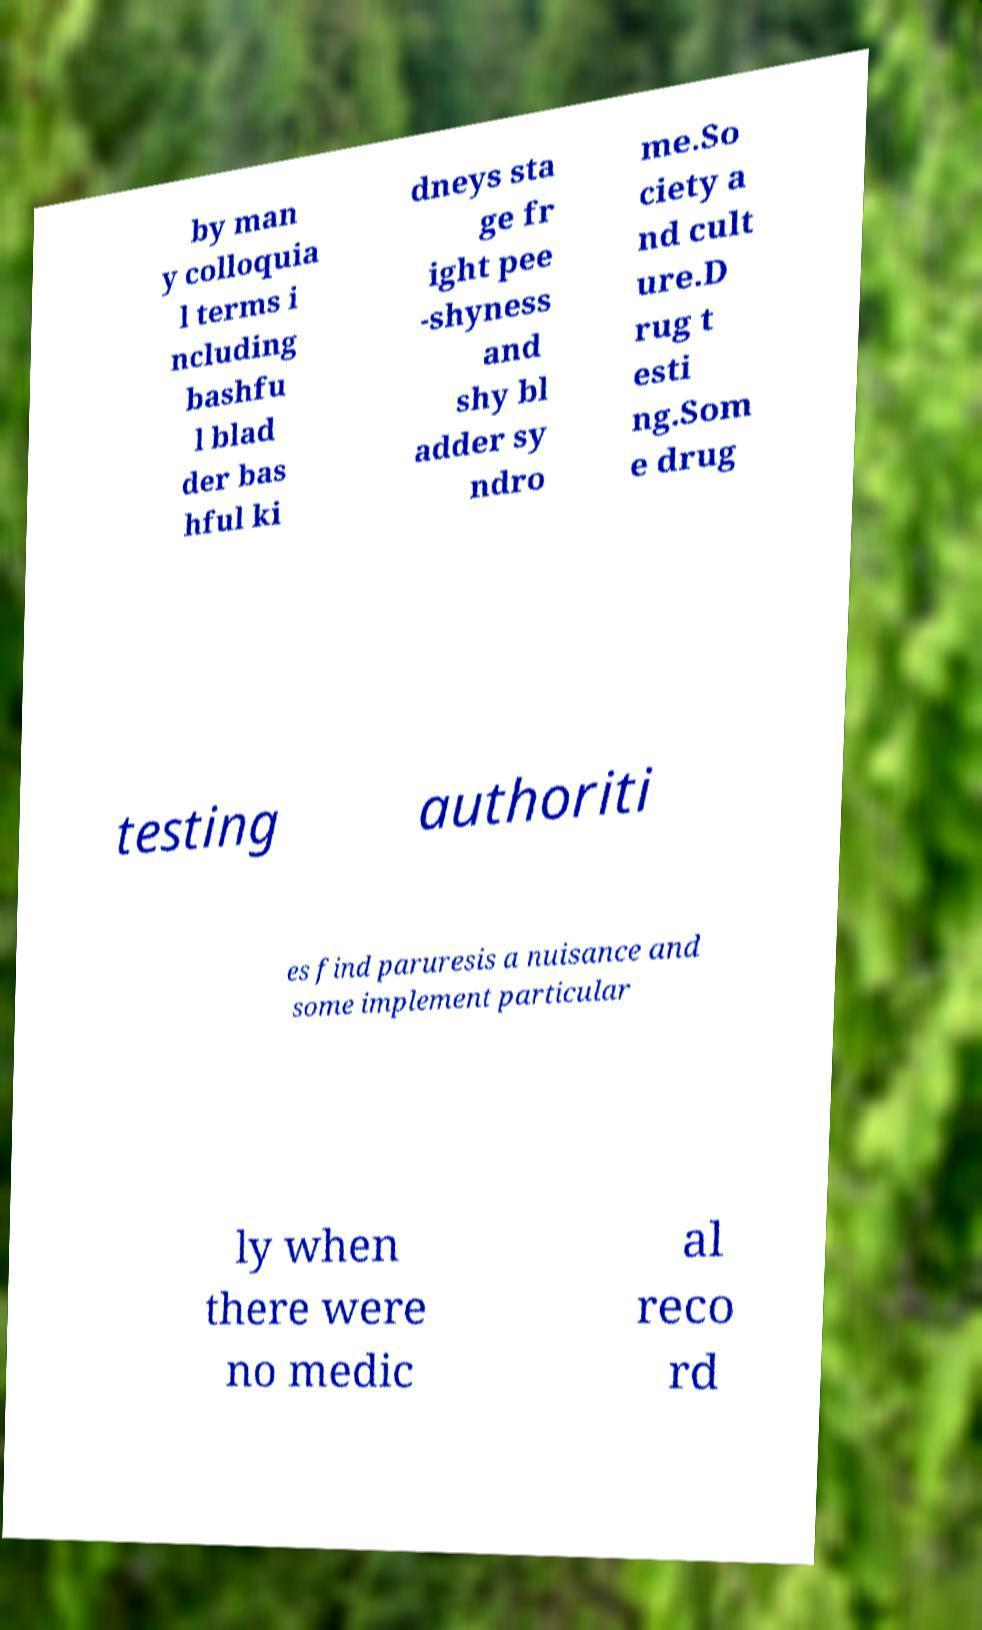What messages or text are displayed in this image? I need them in a readable, typed format. by man y colloquia l terms i ncluding bashfu l blad der bas hful ki dneys sta ge fr ight pee -shyness and shy bl adder sy ndro me.So ciety a nd cult ure.D rug t esti ng.Som e drug testing authoriti es find paruresis a nuisance and some implement particular ly when there were no medic al reco rd 